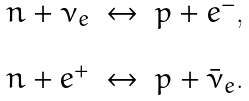<formula> <loc_0><loc_0><loc_500><loc_500>\begin{array} { c c c } n + \nu _ { e } & \leftrightarrow & p + e ^ { - } , \\ \\ n + e ^ { + } & \leftrightarrow & p + \bar { \nu } _ { e } . \end{array}</formula> 